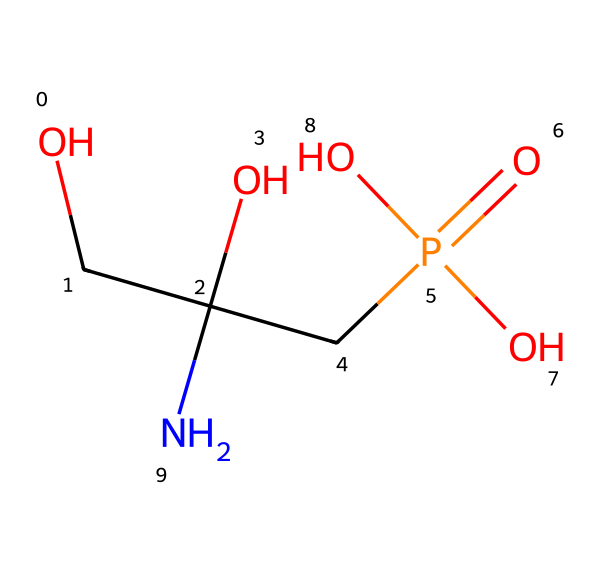What is the main functional group present in glyphosate? The chemical structure contains a phosphorus atom bonded to four oxygens (one double bond), indicating the presence of a phosphate group as a major functional group.
Answer: phosphate group How many carbon atoms are in glyphosate? In the SMILES representation, there are two carbon atoms present in the main chain of the molecule.
Answer: 2 What is the total number of oxygen atoms in glyphosate? The structure shows four oxygen atoms: one double-bonded (C=O) and three single-bonded (two as part of the phosphate group and one in the alcohol group).
Answer: 4 What type of bond connects the nitrogen to the carbon atoms in glyphosate? The nitrogen is connected to the carbon atoms through single bonds, indicated by the lack of specific symbols for double or triple bonding between them.
Answer: single bond What is the oxidation state of phosphorus in glyphosate? In glyphosate, the phosphorus is bonded to four oxygens with varying bonding characteristics, summing it up yields an oxidation state of +5.
Answer: +5 What is the role of the nitrogen atom in glyphosate? The nitrogen atom in the structure serves as an amine functional group that contributes to the herbicidal activity by being involved in hydrogen bonding and interacting with biological systems.
Answer: amine 